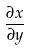<formula> <loc_0><loc_0><loc_500><loc_500>\frac { \partial x } { \partial y }</formula> 